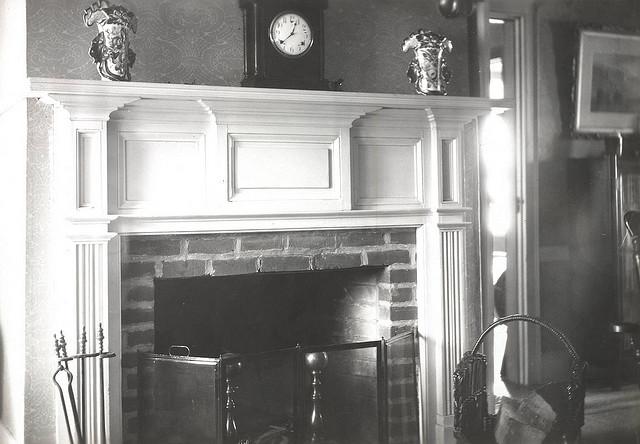Is this photo old?
Short answer required. No. What is on the center of the ledge?
Be succinct. Clock. Is the photo colorful?
Write a very short answer. No. 